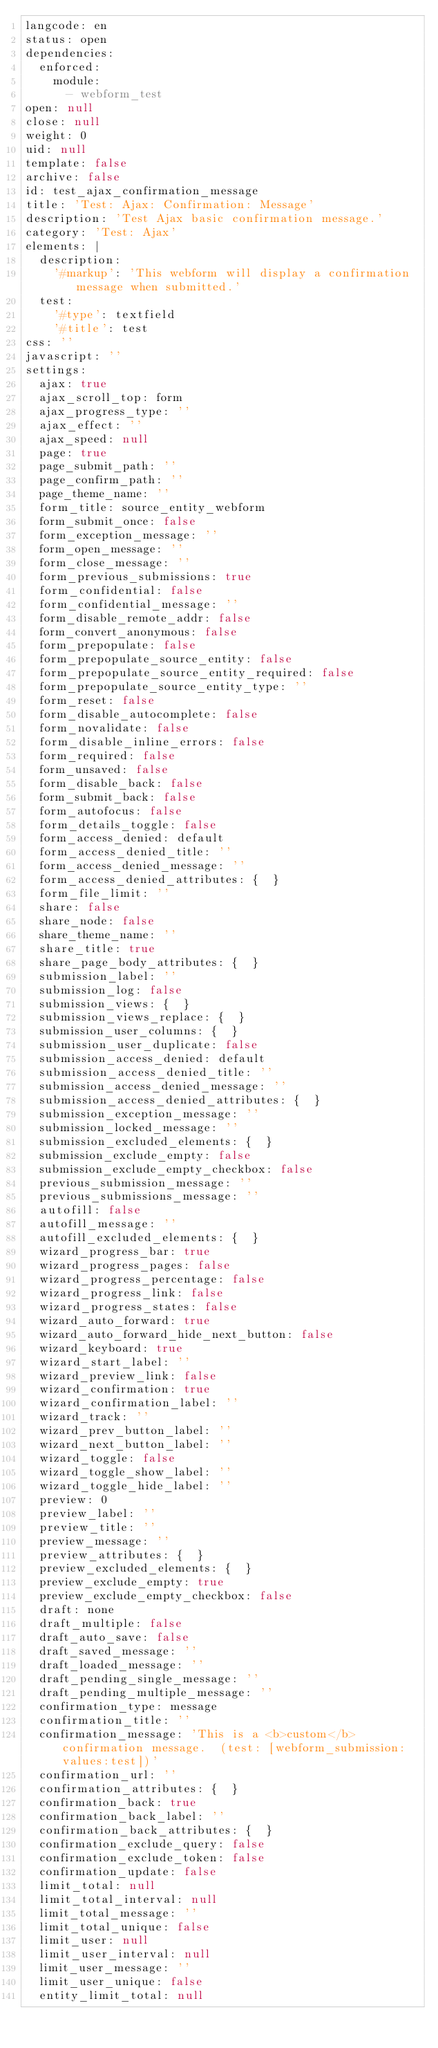<code> <loc_0><loc_0><loc_500><loc_500><_YAML_>langcode: en
status: open
dependencies:
  enforced:
    module:
      - webform_test
open: null
close: null
weight: 0
uid: null
template: false
archive: false
id: test_ajax_confirmation_message
title: 'Test: Ajax: Confirmation: Message'
description: 'Test Ajax basic confirmation message.'
category: 'Test: Ajax'
elements: |
  description:
    '#markup': 'This webform will display a confirmation message when submitted.'
  test:
    '#type': textfield
    '#title': test
css: ''
javascript: ''
settings:
  ajax: true
  ajax_scroll_top: form
  ajax_progress_type: ''
  ajax_effect: ''
  ajax_speed: null
  page: true
  page_submit_path: ''
  page_confirm_path: ''
  page_theme_name: ''
  form_title: source_entity_webform
  form_submit_once: false
  form_exception_message: ''
  form_open_message: ''
  form_close_message: ''
  form_previous_submissions: true
  form_confidential: false
  form_confidential_message: ''
  form_disable_remote_addr: false
  form_convert_anonymous: false
  form_prepopulate: false
  form_prepopulate_source_entity: false
  form_prepopulate_source_entity_required: false
  form_prepopulate_source_entity_type: ''
  form_reset: false
  form_disable_autocomplete: false
  form_novalidate: false
  form_disable_inline_errors: false
  form_required: false
  form_unsaved: false
  form_disable_back: false
  form_submit_back: false
  form_autofocus: false
  form_details_toggle: false
  form_access_denied: default
  form_access_denied_title: ''
  form_access_denied_message: ''
  form_access_denied_attributes: {  }
  form_file_limit: ''
  share: false
  share_node: false
  share_theme_name: ''
  share_title: true
  share_page_body_attributes: {  }
  submission_label: ''
  submission_log: false
  submission_views: {  }
  submission_views_replace: {  }
  submission_user_columns: {  }
  submission_user_duplicate: false
  submission_access_denied: default
  submission_access_denied_title: ''
  submission_access_denied_message: ''
  submission_access_denied_attributes: {  }
  submission_exception_message: ''
  submission_locked_message: ''
  submission_excluded_elements: {  }
  submission_exclude_empty: false
  submission_exclude_empty_checkbox: false
  previous_submission_message: ''
  previous_submissions_message: ''
  autofill: false
  autofill_message: ''
  autofill_excluded_elements: {  }
  wizard_progress_bar: true
  wizard_progress_pages: false
  wizard_progress_percentage: false
  wizard_progress_link: false
  wizard_progress_states: false
  wizard_auto_forward: true
  wizard_auto_forward_hide_next_button: false
  wizard_keyboard: true
  wizard_start_label: ''
  wizard_preview_link: false
  wizard_confirmation: true
  wizard_confirmation_label: ''
  wizard_track: ''
  wizard_prev_button_label: ''
  wizard_next_button_label: ''
  wizard_toggle: false
  wizard_toggle_show_label: ''
  wizard_toggle_hide_label: ''
  preview: 0
  preview_label: ''
  preview_title: ''
  preview_message: ''
  preview_attributes: {  }
  preview_excluded_elements: {  }
  preview_exclude_empty: true
  preview_exclude_empty_checkbox: false
  draft: none
  draft_multiple: false
  draft_auto_save: false
  draft_saved_message: ''
  draft_loaded_message: ''
  draft_pending_single_message: ''
  draft_pending_multiple_message: ''
  confirmation_type: message
  confirmation_title: ''
  confirmation_message: 'This is a <b>custom</b> confirmation message.  (test: [webform_submission:values:test])'
  confirmation_url: ''
  confirmation_attributes: {  }
  confirmation_back: true
  confirmation_back_label: ''
  confirmation_back_attributes: {  }
  confirmation_exclude_query: false
  confirmation_exclude_token: false
  confirmation_update: false
  limit_total: null
  limit_total_interval: null
  limit_total_message: ''
  limit_total_unique: false
  limit_user: null
  limit_user_interval: null
  limit_user_message: ''
  limit_user_unique: false
  entity_limit_total: null</code> 